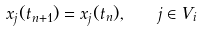<formula> <loc_0><loc_0><loc_500><loc_500>x _ { j } ( t _ { n + 1 } ) = x _ { j } ( t _ { n } ) , \quad j \in V _ { i }</formula> 